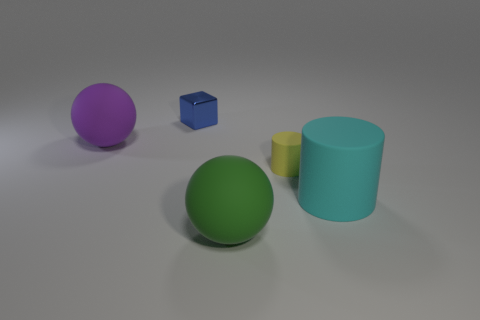Add 2 green spheres. How many objects exist? 7 Subtract all balls. How many objects are left? 3 Add 3 large matte balls. How many large matte balls are left? 5 Add 3 cyan balls. How many cyan balls exist? 3 Subtract 1 purple balls. How many objects are left? 4 Subtract all green balls. Subtract all green spheres. How many objects are left? 3 